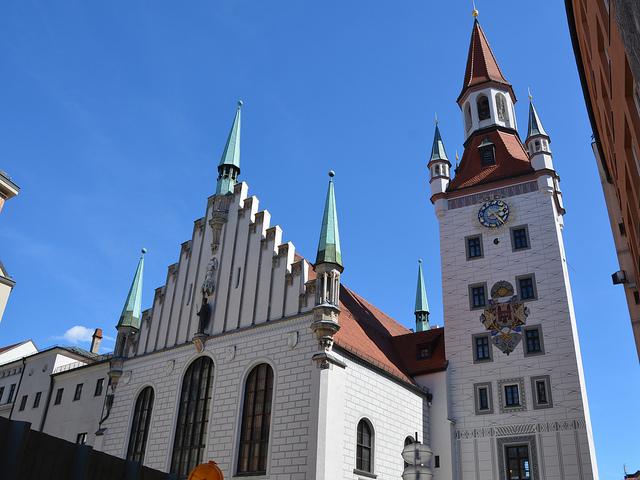What is the color of the sky?
Give a very brief answer. Blue. Where is the clock?
Quick response, please. Tower. What color is the building?
Write a very short answer. White. 